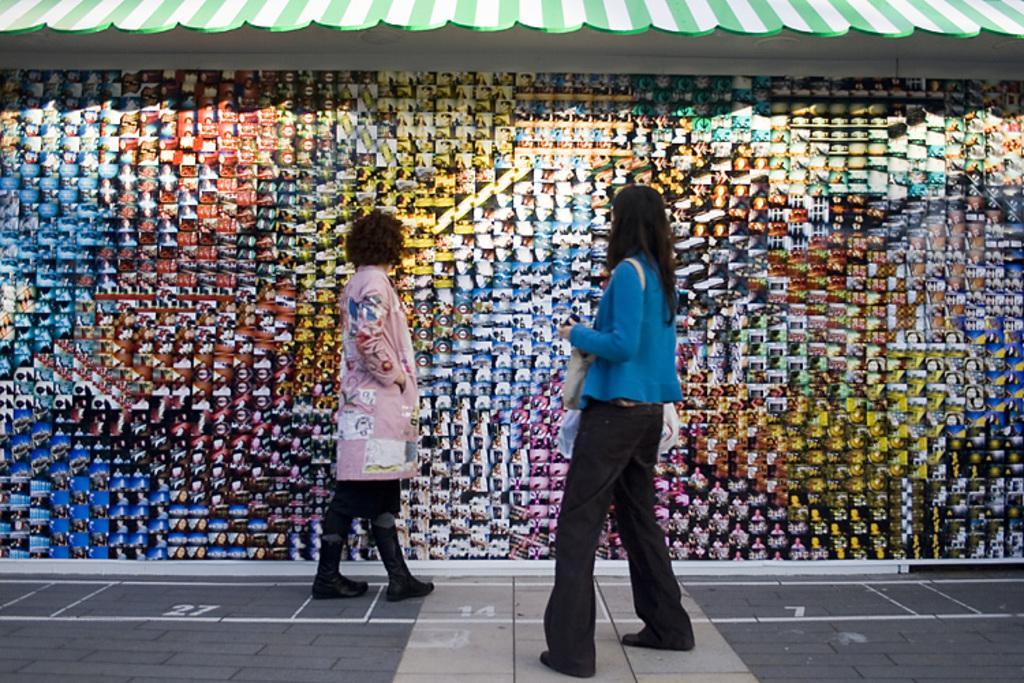In one or two sentences, can you explain what this image depicts? In this image we can see two lady persons, in the foreground of the image there is a woman wearing blue color top and black color jeans, also carrying white color bag standing and in the background of the image there is a woman wearing pink color top and black color pant, shoes standing near the wall on which there are some pictures attached and top of the image there is roof which is green in color. 